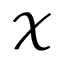Convert formula to latex. <formula><loc_0><loc_0><loc_500><loc_500>\mathcal { X }</formula> 